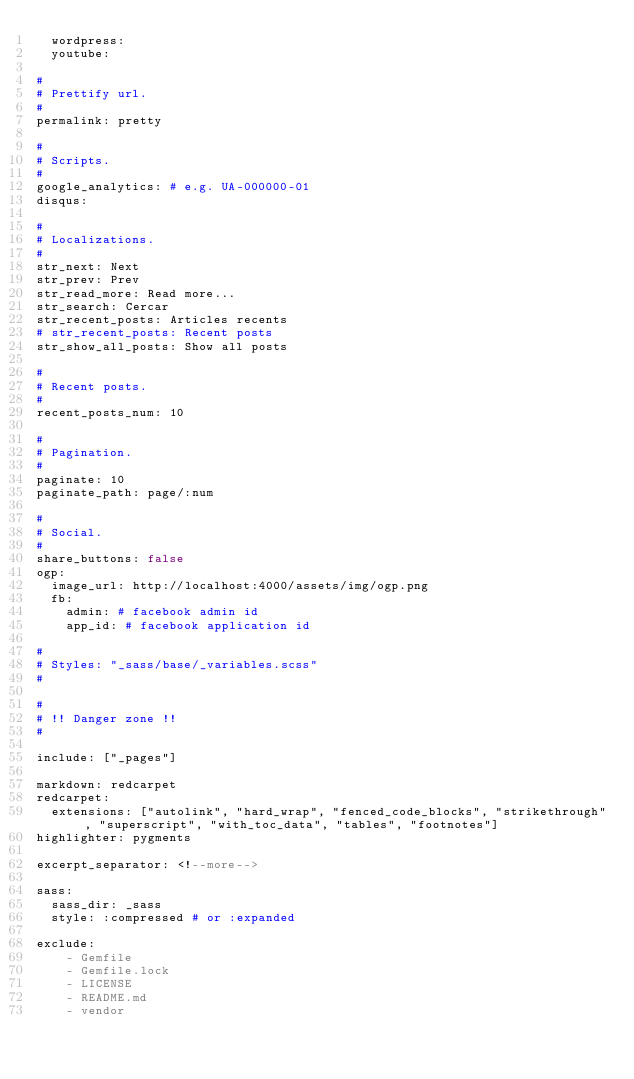Convert code to text. <code><loc_0><loc_0><loc_500><loc_500><_YAML_>  wordpress: 
  youtube:

#
# Prettify url.
#
permalink: pretty

#
# Scripts.
#
google_analytics: # e.g. UA-000000-01
disqus:

#
# Localizations.
#
str_next: Next
str_prev: Prev
str_read_more: Read more...
str_search: Cercar
str_recent_posts: Articles recents
# str_recent_posts: Recent posts
str_show_all_posts: Show all posts

#
# Recent posts.
#
recent_posts_num: 10

#
# Pagination.
#
paginate: 10
paginate_path: page/:num

#
# Social.
#
share_buttons: false
ogp:
  image_url: http://localhost:4000/assets/img/ogp.png
  fb:
    admin: # facebook admin id
    app_id: # facebook application id

#
# Styles: "_sass/base/_variables.scss"
#

#
# !! Danger zone !!
#

include: ["_pages"]

markdown: redcarpet
redcarpet:
  extensions: ["autolink", "hard_wrap", "fenced_code_blocks", "strikethrough", "superscript", "with_toc_data", "tables", "footnotes"]
highlighter: pygments

excerpt_separator: <!--more-->

sass:
  sass_dir: _sass
  style: :compressed # or :expanded

exclude:
    - Gemfile
    - Gemfile.lock
    - LICENSE
    - README.md
    - vendor
</code> 